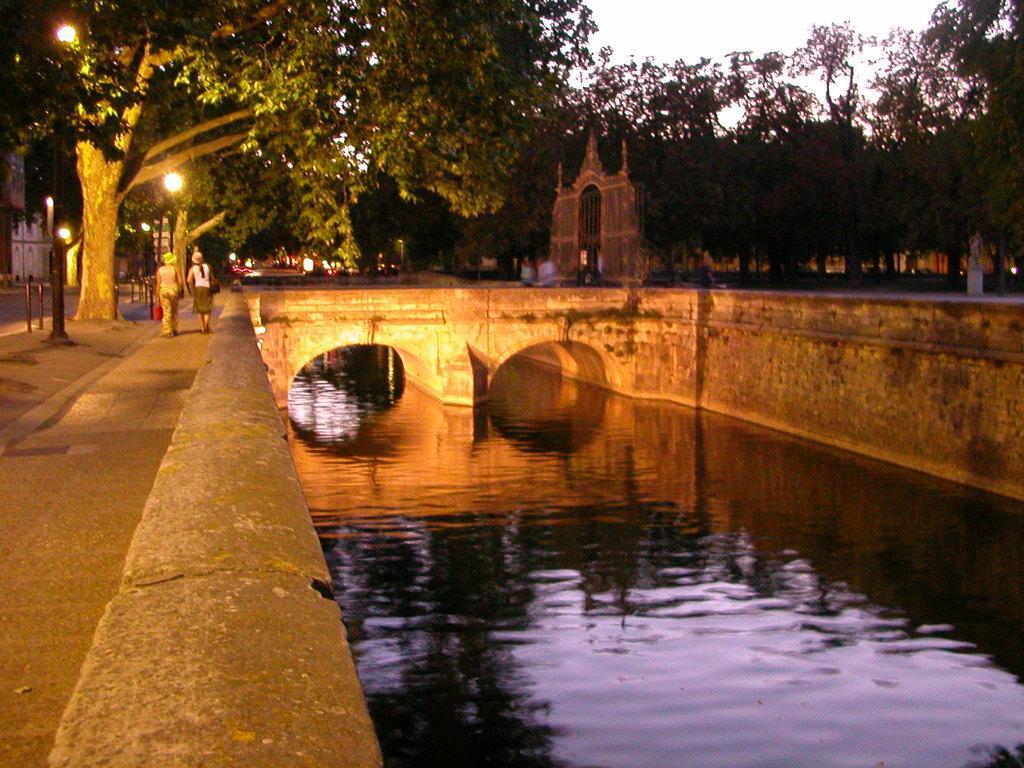Describe this image in one or two sentences. In this image I can see the water. To the side of the water I can see few people walking with different color dresses. And also I can see many light poles and trees. In the background I can see the arch, many trees and the white sky. 